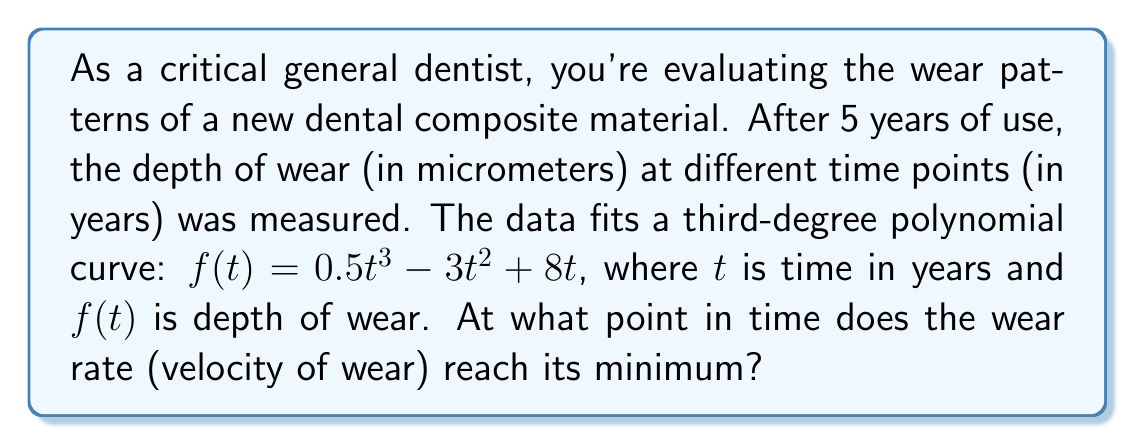Show me your answer to this math problem. To find the minimum wear rate, we need to follow these steps:

1) The wear rate is represented by the first derivative of the wear function $f(t)$. Let's call this $f'(t)$.

2) Calculate $f'(t)$:
   $f'(t) = \frac{d}{dt}(0.5t^3 - 3t^2 + 8t)$
   $f'(t) = 1.5t^2 - 6t + 8$

3) To find the minimum wear rate, we need to find where the second derivative $f''(t)$ equals zero:
   $f''(t) = \frac{d}{dt}(1.5t^2 - 6t + 8)$
   $f''(t) = 3t - 6$

4) Set $f''(t) = 0$ and solve for $t$:
   $3t - 6 = 0$
   $3t = 6$
   $t = 2$

5) To confirm this is a minimum (not a maximum), check that $f'''(t) > 0$:
   $f'''(t) = 3$, which is indeed positive.

Therefore, the wear rate reaches its minimum at $t = 2$ years.
Answer: 2 years 